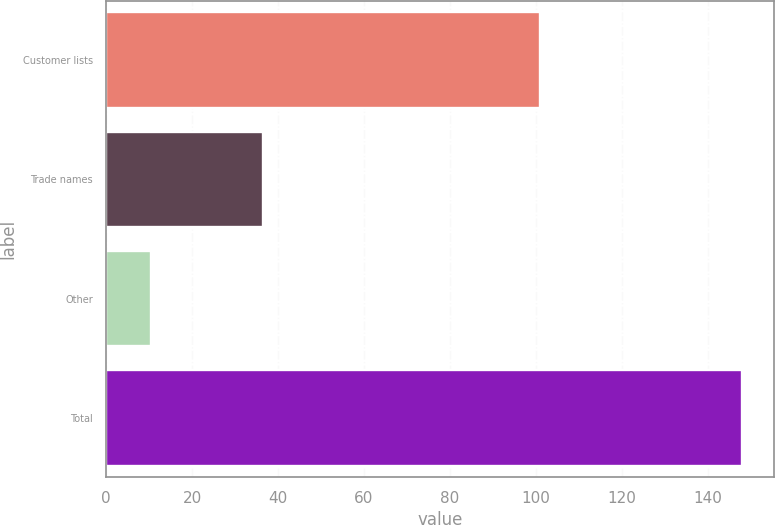<chart> <loc_0><loc_0><loc_500><loc_500><bar_chart><fcel>Customer lists<fcel>Trade names<fcel>Other<fcel>Total<nl><fcel>101<fcel>36.6<fcel>10.5<fcel>148.1<nl></chart> 